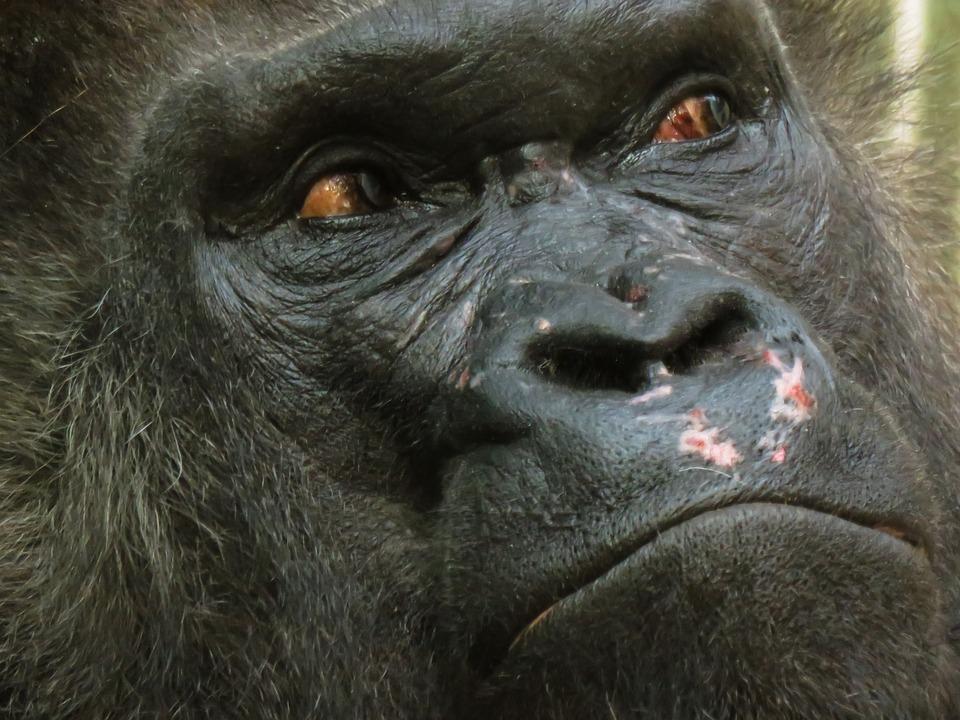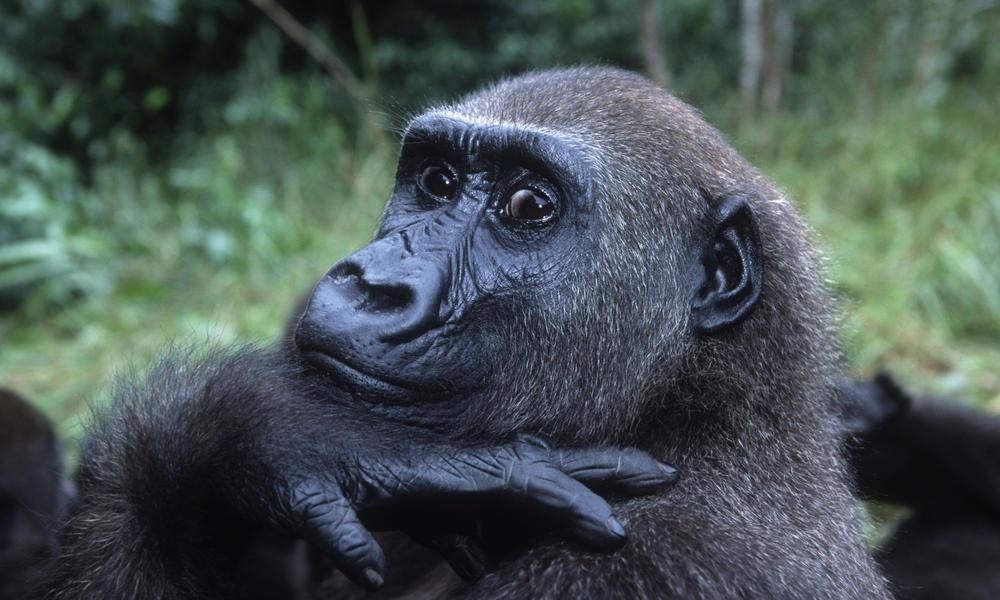The first image is the image on the left, the second image is the image on the right. Analyze the images presented: Is the assertion "The gorilla in the right image rests its hand against part of its own body." valid? Answer yes or no. Yes. 